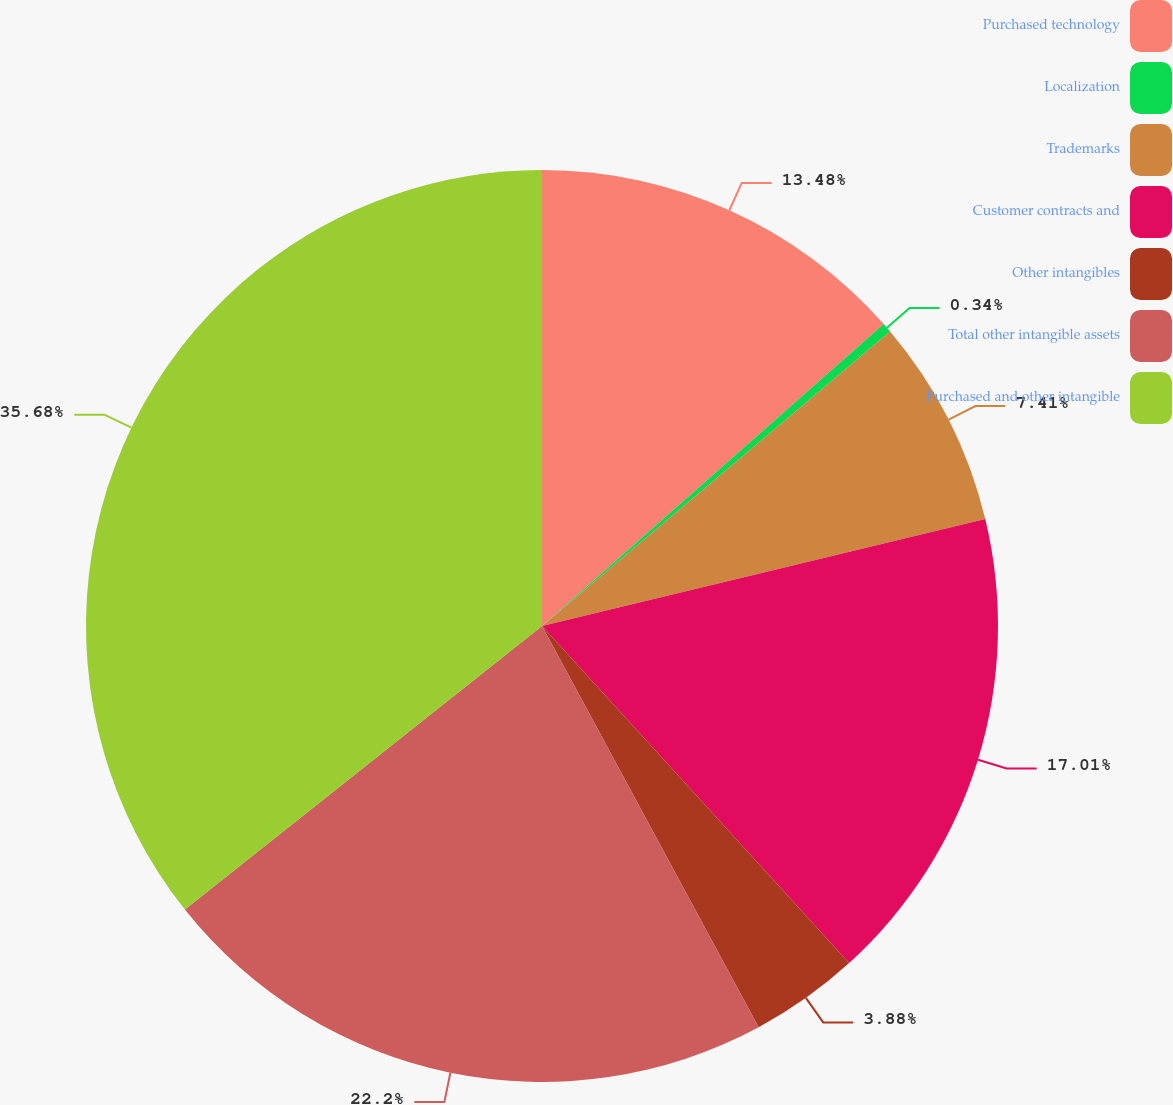Convert chart to OTSL. <chart><loc_0><loc_0><loc_500><loc_500><pie_chart><fcel>Purchased technology<fcel>Localization<fcel>Trademarks<fcel>Customer contracts and<fcel>Other intangibles<fcel>Total other intangible assets<fcel>Purchased and other intangible<nl><fcel>13.48%<fcel>0.34%<fcel>7.41%<fcel>17.01%<fcel>3.88%<fcel>22.2%<fcel>35.68%<nl></chart> 